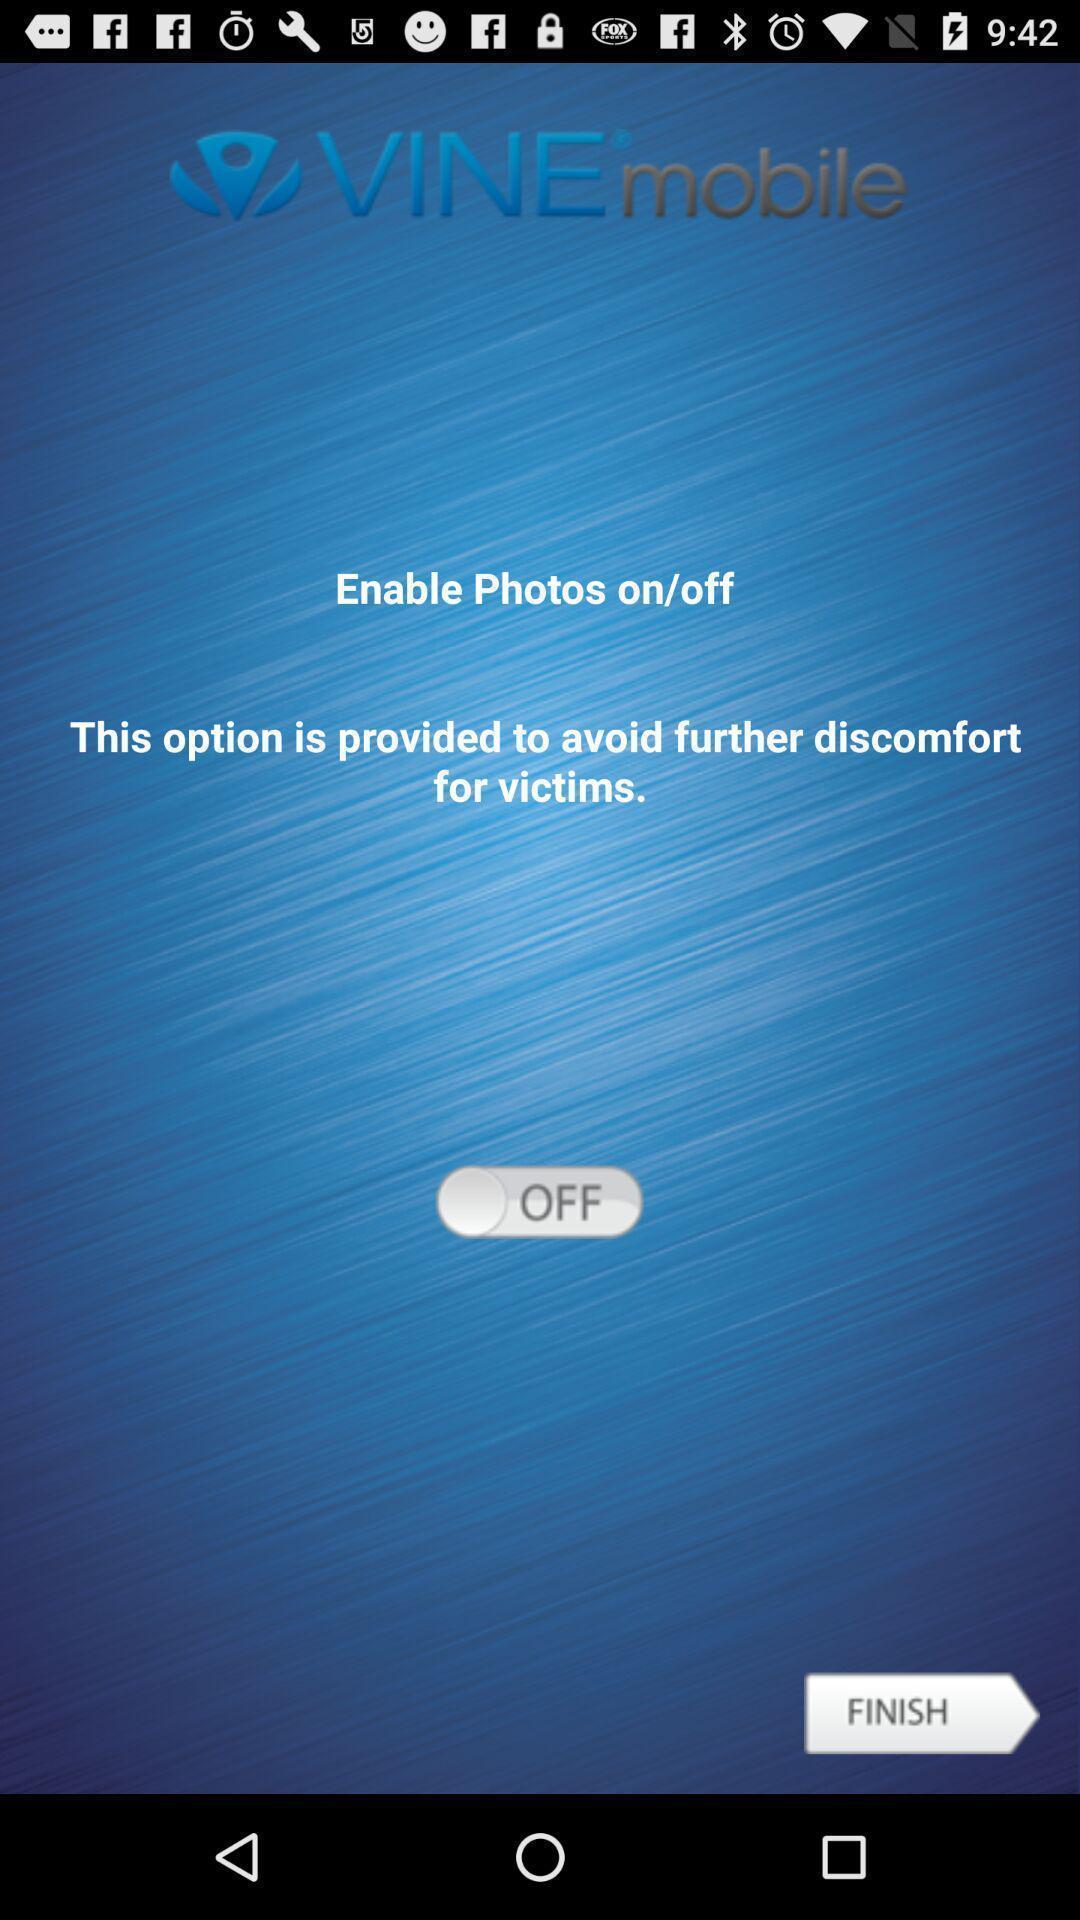Provide a description of this screenshot. Screen shows to enable photos. 